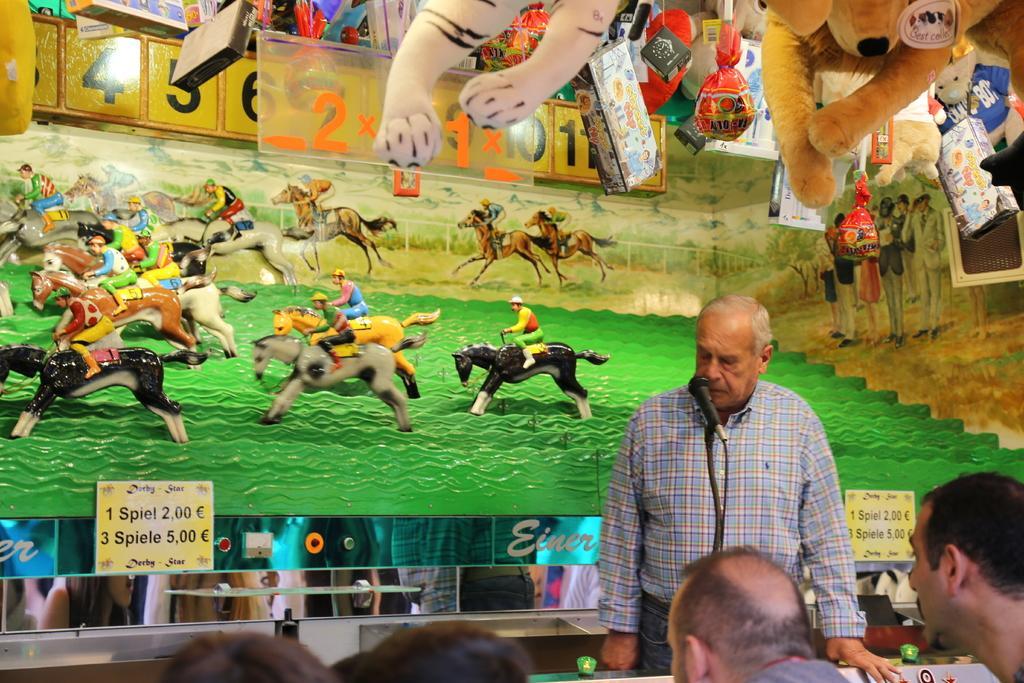Describe this image in one or two sentences. In this picture a man is talking in front of a mic and spectators are sitting on the chairs. In the background we observe a frame on which horse toys are placed and there are toys attached to the roof. There is also a poster on which 1 spiele 1 Euro , 3 spiele 5 Euros is written. 